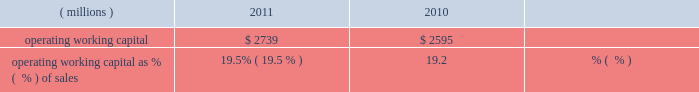Liquidity and capital resources during the past three years , we had sufficient financial resources to meet our operating requirements , to fund our capital spending , share repurchases and pension plans and to pay increasing dividends to our shareholders .
Cash from operating activities was $ 1436 million , $ 1310 million , and $ 1345 million in 2011 , 2010 , and 2009 , respectively .
Higher earnings increased cash from operations in 2011 compared to 2010 , but the increase was reduced by cash used to fund an increase in working capital of $ 212 million driven by our sales growth in 2011 .
Cash provided by working capital was greater in 2009 than 2010 and that decline was more than offset by the cash from higher 2010 earnings .
Operating working capital is a subset of total working capital and represents ( 1 ) trade receivables-net of the allowance for doubtful accounts , plus ( 2 ) inventories on a first-in , first-out ( 201cfifo 201d ) basis , less ( 3 ) trade creditors 2019 liabilities .
See note 3 , 201cworking capital detail 201d under item 8 of this form 10-k for further information related to the components of the company 2019s operating working capital .
We believe operating working capital represents the key components of working capital under the operating control of our businesses .
Operating working capital at december 31 , 2011 and 2010 was $ 2.7 billion and $ 2.6 billion , respectively .
A key metric we use to measure our working capital management is operating working capital as a percentage of sales ( fourth quarter sales annualized ) .
( millions ) 2011 2010 operating working capital $ 2739 $ 2595 operating working capital as % (  % ) of sales 19.5% ( 19.5 % ) 19.2% ( 19.2 % ) the change in operating working capital elements , excluding the impact of currency and acquisitions , was an increase of $ 195 million during the year ended december 31 , 2011 .
This increase was the net result of an increase in receivables from customers associated with the 2011 increase in sales and an increase in fifo inventory slightly offset by an increase in trade creditors 2019 liabilities .
Trade receivables from customers , net , as a percentage of fourth quarter sales , annualized , for 2011 was 17.9 percent , down slightly from 18.1 percent for 2010 .
Days sales outstanding was 66 days in 2011 , level with 2010 .
Inventories on a fifo basis as a percentage of fourth quarter sales , annualized , for 2011 was 13.1 percent level with 2010 .
Inventory turnover was 5.0 times in 2011 and 4.6 times in 2010 .
Total capital spending , including acquisitions , was $ 446 million , $ 341 million and $ 265 million in 2011 , 2010 , and 2009 , respectively .
Spending related to modernization and productivity improvements , expansion of existing businesses and environmental control projects was $ 390 million , $ 307 million and $ 239 million in 2011 , 2010 , and 2009 , respectively , and is expected to be in the range of $ 450-$ 550 million during 2012 .
Capital spending , excluding acquisitions , as a percentage of sales was 2.6% ( 2.6 % ) , 2.3% ( 2.3 % ) and 2.0% ( 2.0 % ) in 2011 , 2010 and 2009 , respectively .
Capital spending related to business acquisitions amounted to $ 56 million , $ 34 million , and $ 26 million in 2011 , 2010 and 2009 , respectively .
We continue to evaluate acquisition opportunities and expect to use cash in 2012 to fund small to mid-sized acquisitions , as part of a balanced deployment of our cash to support growth in earnings .
In january 2012 , the company closed the previously announced acquisitions of colpisa , a colombian producer of automotive oem and refinish coatings , and dyrup , a european architectural coatings company .
The cost of these acquisitions , including assumed debt , was $ 193 million .
Dividends paid to shareholders totaled $ 355 million , $ 360 million and $ 353 million in 2011 , 2010 and 2009 , respectively .
Ppg has paid uninterrupted annual dividends since 1899 , and 2011 marked the 40th consecutive year of increased annual dividend payments to shareholders .
We did not have a mandatory contribution to our u.s .
Defined benefit pension plans in 2011 ; however , we made voluntary contributions to these plans in 2011 totaling $ 50 million .
In 2010 and 2009 , we made voluntary contributions to our u.s .
Defined benefit pension plans of $ 250 and $ 360 million ( of which $ 100 million was made in ppg stock ) , respectively .
We expect to make voluntary contributions to our u.s .
Defined benefit pension plans in 2012 of up to $ 60 million .
Contributions were made to our non-u.s .
Defined benefit pension plans of $ 71 million , $ 87 million and $ 90 million ( of which approximately $ 20 million was made in ppg stock ) for 2011 , 2010 and 2009 , respectively , some of which were required by local funding requirements .
We expect to make mandatory contributions to our non-u.s .
Plans in 2012 of approximately $ 90 million .
The company 2019s share repurchase activity in 2011 , 2010 and 2009 was 10.2 million shares at a cost of $ 858 million , 8.1 million shares at a cost of $ 586 million and 1.5 million shares at a cost of $ 59 million , respectively .
We expect to make share repurchases in 2012 as part of our cash deployment focused on earnings growth .
The amount of spending will depend on the level of acquisition spending and other uses of cash , but we currently expect to spend in the range of $ 250 million to $ 500 million on share repurchases in 2012 .
We can repurchase about 9 million shares under the current authorization from the board of directors .
26 2011 ppg annual report and form 10-k .
Liquidity and capital resources during the past three years , we had sufficient financial resources to meet our operating requirements , to fund our capital spending , share repurchases and pension plans and to pay increasing dividends to our shareholders .
Cash from operating activities was $ 1436 million , $ 1310 million , and $ 1345 million in 2011 , 2010 , and 2009 , respectively .
Higher earnings increased cash from operations in 2011 compared to 2010 , but the increase was reduced by cash used to fund an increase in working capital of $ 212 million driven by our sales growth in 2011 .
Cash provided by working capital was greater in 2009 than 2010 and that decline was more than offset by the cash from higher 2010 earnings .
Operating working capital is a subset of total working capital and represents ( 1 ) trade receivables-net of the allowance for doubtful accounts , plus ( 2 ) inventories on a first-in , first-out ( 201cfifo 201d ) basis , less ( 3 ) trade creditors 2019 liabilities .
See note 3 , 201cworking capital detail 201d under item 8 of this form 10-k for further information related to the components of the company 2019s operating working capital .
We believe operating working capital represents the key components of working capital under the operating control of our businesses .
Operating working capital at december 31 , 2011 and 2010 was $ 2.7 billion and $ 2.6 billion , respectively .
A key metric we use to measure our working capital management is operating working capital as a percentage of sales ( fourth quarter sales annualized ) .
( millions ) 2011 2010 operating working capital $ 2739 $ 2595 operating working capital as % (  % ) of sales 19.5% ( 19.5 % ) 19.2% ( 19.2 % ) the change in operating working capital elements , excluding the impact of currency and acquisitions , was an increase of $ 195 million during the year ended december 31 , 2011 .
This increase was the net result of an increase in receivables from customers associated with the 2011 increase in sales and an increase in fifo inventory slightly offset by an increase in trade creditors 2019 liabilities .
Trade receivables from customers , net , as a percentage of fourth quarter sales , annualized , for 2011 was 17.9 percent , down slightly from 18.1 percent for 2010 .
Days sales outstanding was 66 days in 2011 , level with 2010 .
Inventories on a fifo basis as a percentage of fourth quarter sales , annualized , for 2011 was 13.1 percent level with 2010 .
Inventory turnover was 5.0 times in 2011 and 4.6 times in 2010 .
Total capital spending , including acquisitions , was $ 446 million , $ 341 million and $ 265 million in 2011 , 2010 , and 2009 , respectively .
Spending related to modernization and productivity improvements , expansion of existing businesses and environmental control projects was $ 390 million , $ 307 million and $ 239 million in 2011 , 2010 , and 2009 , respectively , and is expected to be in the range of $ 450-$ 550 million during 2012 .
Capital spending , excluding acquisitions , as a percentage of sales was 2.6% ( 2.6 % ) , 2.3% ( 2.3 % ) and 2.0% ( 2.0 % ) in 2011 , 2010 and 2009 , respectively .
Capital spending related to business acquisitions amounted to $ 56 million , $ 34 million , and $ 26 million in 2011 , 2010 and 2009 , respectively .
We continue to evaluate acquisition opportunities and expect to use cash in 2012 to fund small to mid-sized acquisitions , as part of a balanced deployment of our cash to support growth in earnings .
In january 2012 , the company closed the previously announced acquisitions of colpisa , a colombian producer of automotive oem and refinish coatings , and dyrup , a european architectural coatings company .
The cost of these acquisitions , including assumed debt , was $ 193 million .
Dividends paid to shareholders totaled $ 355 million , $ 360 million and $ 353 million in 2011 , 2010 and 2009 , respectively .
Ppg has paid uninterrupted annual dividends since 1899 , and 2011 marked the 40th consecutive year of increased annual dividend payments to shareholders .
We did not have a mandatory contribution to our u.s .
Defined benefit pension plans in 2011 ; however , we made voluntary contributions to these plans in 2011 totaling $ 50 million .
In 2010 and 2009 , we made voluntary contributions to our u.s .
Defined benefit pension plans of $ 250 and $ 360 million ( of which $ 100 million was made in ppg stock ) , respectively .
We expect to make voluntary contributions to our u.s .
Defined benefit pension plans in 2012 of up to $ 60 million .
Contributions were made to our non-u.s .
Defined benefit pension plans of $ 71 million , $ 87 million and $ 90 million ( of which approximately $ 20 million was made in ppg stock ) for 2011 , 2010 and 2009 , respectively , some of which were required by local funding requirements .
We expect to make mandatory contributions to our non-u.s .
Plans in 2012 of approximately $ 90 million .
The company 2019s share repurchase activity in 2011 , 2010 and 2009 was 10.2 million shares at a cost of $ 858 million , 8.1 million shares at a cost of $ 586 million and 1.5 million shares at a cost of $ 59 million , respectively .
We expect to make share repurchases in 2012 as part of our cash deployment focused on earnings growth .
The amount of spending will depend on the level of acquisition spending and other uses of cash , but we currently expect to spend in the range of $ 250 million to $ 500 million on share repurchases in 2012 .
We can repurchase about 9 million shares under the current authorization from the board of directors .
26 2011 ppg annual report and form 10-k .
Based on the cost per share of the repurchase activity in 2011 , how much would it cost to repurchase the remaining shares under the current authorization from the board of directors? 
Computations: (((858 / 10.2) * 9) * 1000000)
Answer: 757058823.52941. 